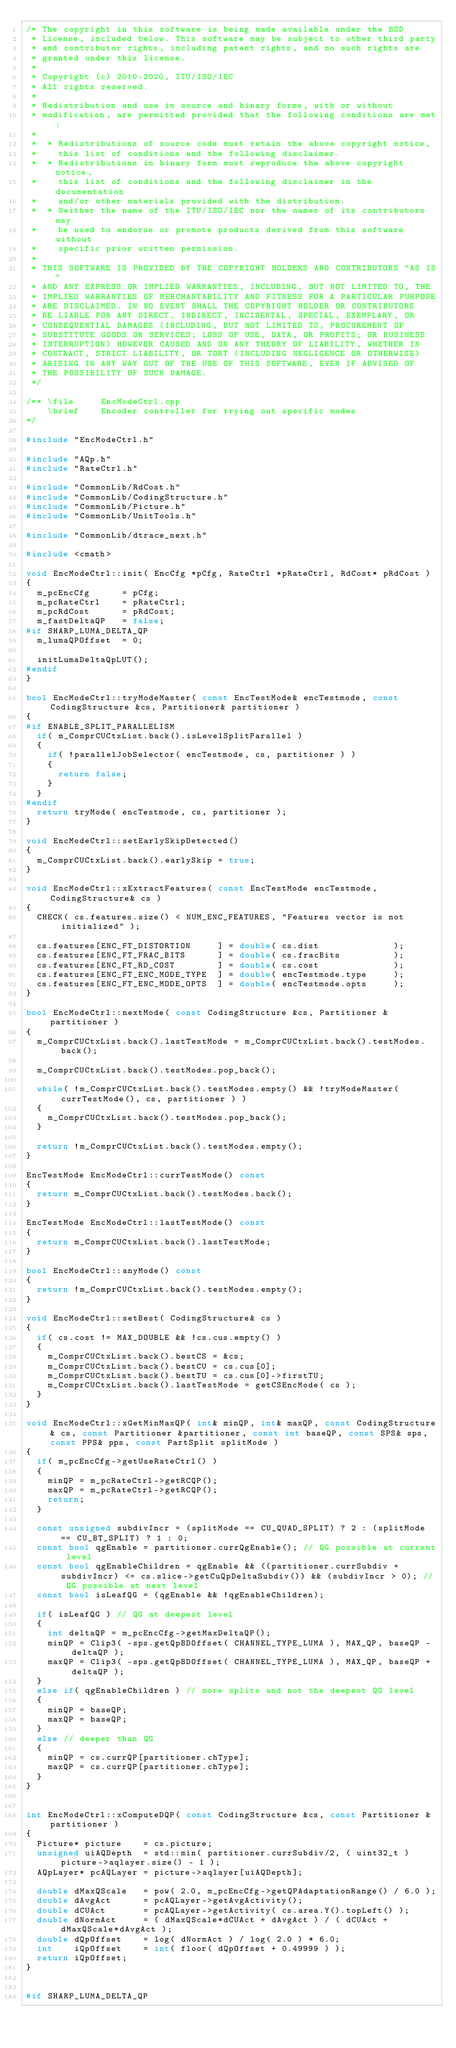<code> <loc_0><loc_0><loc_500><loc_500><_C++_>/* The copyright in this software is being made available under the BSD
 * License, included below. This software may be subject to other third party
 * and contributor rights, including patent rights, and no such rights are
 * granted under this license.
 *
 * Copyright (c) 2010-2020, ITU/ISO/IEC
 * All rights reserved.
 *
 * Redistribution and use in source and binary forms, with or without
 * modification, are permitted provided that the following conditions are met:
 *
 *  * Redistributions of source code must retain the above copyright notice,
 *    this list of conditions and the following disclaimer.
 *  * Redistributions in binary form must reproduce the above copyright notice,
 *    this list of conditions and the following disclaimer in the documentation
 *    and/or other materials provided with the distribution.
 *  * Neither the name of the ITU/ISO/IEC nor the names of its contributors may
 *    be used to endorse or promote products derived from this software without
 *    specific prior written permission.
 *
 * THIS SOFTWARE IS PROVIDED BY THE COPYRIGHT HOLDERS AND CONTRIBUTORS "AS IS"
 * AND ANY EXPRESS OR IMPLIED WARRANTIES, INCLUDING, BUT NOT LIMITED TO, THE
 * IMPLIED WARRANTIES OF MERCHANTABILITY AND FITNESS FOR A PARTICULAR PURPOSE
 * ARE DISCLAIMED. IN NO EVENT SHALL THE COPYRIGHT HOLDER OR CONTRIBUTORS
 * BE LIABLE FOR ANY DIRECT, INDIRECT, INCIDENTAL, SPECIAL, EXEMPLARY, OR
 * CONSEQUENTIAL DAMAGES (INCLUDING, BUT NOT LIMITED TO, PROCUREMENT OF
 * SUBSTITUTE GOODS OR SERVICES; LOSS OF USE, DATA, OR PROFITS; OR BUSINESS
 * INTERRUPTION) HOWEVER CAUSED AND ON ANY THEORY OF LIABILITY, WHETHER IN
 * CONTRACT, STRICT LIABILITY, OR TORT (INCLUDING NEGLIGENCE OR OTHERWISE)
 * ARISING IN ANY WAY OUT OF THE USE OF THIS SOFTWARE, EVEN IF ADVISED OF
 * THE POSSIBILITY OF SUCH DAMAGE.
 */

/** \file     EncModeCtrl.cpp
    \brief    Encoder controller for trying out specific modes
*/

#include "EncModeCtrl.h"

#include "AQp.h"
#include "RateCtrl.h"

#include "CommonLib/RdCost.h"
#include "CommonLib/CodingStructure.h"
#include "CommonLib/Picture.h"
#include "CommonLib/UnitTools.h"

#include "CommonLib/dtrace_next.h"

#include <cmath>

void EncModeCtrl::init( EncCfg *pCfg, RateCtrl *pRateCtrl, RdCost* pRdCost )
{
  m_pcEncCfg      = pCfg;
  m_pcRateCtrl    = pRateCtrl;
  m_pcRdCost      = pRdCost;
  m_fastDeltaQP   = false;
#if SHARP_LUMA_DELTA_QP
  m_lumaQPOffset  = 0;

  initLumaDeltaQpLUT();
#endif
}

bool EncModeCtrl::tryModeMaster( const EncTestMode& encTestmode, const CodingStructure &cs, Partitioner& partitioner )
{
#if ENABLE_SPLIT_PARALLELISM
  if( m_ComprCUCtxList.back().isLevelSplitParallel )
  {
    if( !parallelJobSelector( encTestmode, cs, partitioner ) )
    {
      return false;
    }
  }
#endif
  return tryMode( encTestmode, cs, partitioner );
}

void EncModeCtrl::setEarlySkipDetected()
{
  m_ComprCUCtxList.back().earlySkip = true;
}

void EncModeCtrl::xExtractFeatures( const EncTestMode encTestmode, CodingStructure& cs )
{
  CHECK( cs.features.size() < NUM_ENC_FEATURES, "Features vector is not initialized" );

  cs.features[ENC_FT_DISTORTION     ] = double( cs.dist              );
  cs.features[ENC_FT_FRAC_BITS      ] = double( cs.fracBits          );
  cs.features[ENC_FT_RD_COST        ] = double( cs.cost              );
  cs.features[ENC_FT_ENC_MODE_TYPE  ] = double( encTestmode.type     );
  cs.features[ENC_FT_ENC_MODE_OPTS  ] = double( encTestmode.opts     );
}

bool EncModeCtrl::nextMode( const CodingStructure &cs, Partitioner &partitioner )
{
  m_ComprCUCtxList.back().lastTestMode = m_ComprCUCtxList.back().testModes.back();

  m_ComprCUCtxList.back().testModes.pop_back();

  while( !m_ComprCUCtxList.back().testModes.empty() && !tryModeMaster( currTestMode(), cs, partitioner ) )
  {
    m_ComprCUCtxList.back().testModes.pop_back();
  }

  return !m_ComprCUCtxList.back().testModes.empty();
}

EncTestMode EncModeCtrl::currTestMode() const
{
  return m_ComprCUCtxList.back().testModes.back();
}

EncTestMode EncModeCtrl::lastTestMode() const
{
  return m_ComprCUCtxList.back().lastTestMode;
}

bool EncModeCtrl::anyMode() const
{
  return !m_ComprCUCtxList.back().testModes.empty();
}

void EncModeCtrl::setBest( CodingStructure& cs )
{
  if( cs.cost != MAX_DOUBLE && !cs.cus.empty() )
  {
    m_ComprCUCtxList.back().bestCS = &cs;
    m_ComprCUCtxList.back().bestCU = cs.cus[0];
    m_ComprCUCtxList.back().bestTU = cs.cus[0]->firstTU;
    m_ComprCUCtxList.back().lastTestMode = getCSEncMode( cs );
  }
}

void EncModeCtrl::xGetMinMaxQP( int& minQP, int& maxQP, const CodingStructure& cs, const Partitioner &partitioner, const int baseQP, const SPS& sps, const PPS& pps, const PartSplit splitMode )
{
  if( m_pcEncCfg->getUseRateCtrl() )
  {
    minQP = m_pcRateCtrl->getRCQP();
    maxQP = m_pcRateCtrl->getRCQP();
    return;
  }

  const unsigned subdivIncr = (splitMode == CU_QUAD_SPLIT) ? 2 : (splitMode == CU_BT_SPLIT) ? 1 : 0;
  const bool qgEnable = partitioner.currQgEnable(); // QG possible at current level
  const bool qgEnableChildren = qgEnable && ((partitioner.currSubdiv + subdivIncr) <= cs.slice->getCuQpDeltaSubdiv()) && (subdivIncr > 0); // QG possible at next level
  const bool isLeafQG = (qgEnable && !qgEnableChildren);

  if( isLeafQG ) // QG at deepest level
  {
    int deltaQP = m_pcEncCfg->getMaxDeltaQP();
    minQP = Clip3( -sps.getQpBDOffset( CHANNEL_TYPE_LUMA ), MAX_QP, baseQP - deltaQP );
    maxQP = Clip3( -sps.getQpBDOffset( CHANNEL_TYPE_LUMA ), MAX_QP, baseQP + deltaQP );
  }
  else if( qgEnableChildren ) // more splits and not the deepest QG level
  {
    minQP = baseQP;
    maxQP = baseQP;
  }
  else // deeper than QG
  {
    minQP = cs.currQP[partitioner.chType];
    maxQP = cs.currQP[partitioner.chType];
  }
}


int EncModeCtrl::xComputeDQP( const CodingStructure &cs, const Partitioner &partitioner )
{
  Picture* picture    = cs.picture;
  unsigned uiAQDepth  = std::min( partitioner.currSubdiv/2, ( uint32_t ) picture->aqlayer.size() - 1 );
  AQpLayer* pcAQLayer = picture->aqlayer[uiAQDepth];

  double dMaxQScale   = pow( 2.0, m_pcEncCfg->getQPAdaptationRange() / 6.0 );
  double dAvgAct      = pcAQLayer->getAvgActivity();
  double dCUAct       = pcAQLayer->getActivity( cs.area.Y().topLeft() );
  double dNormAct     = ( dMaxQScale*dCUAct + dAvgAct ) / ( dCUAct + dMaxQScale*dAvgAct );
  double dQpOffset    = log( dNormAct ) / log( 2.0 ) * 6.0;
  int    iQpOffset    = int( floor( dQpOffset + 0.49999 ) );
  return iQpOffset;
}


#if SHARP_LUMA_DELTA_QP</code> 